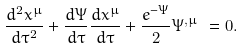Convert formula to latex. <formula><loc_0><loc_0><loc_500><loc_500>\frac { d ^ { 2 } x ^ { \mu } } { d \tau ^ { 2 } } + \frac { d \Psi } { d \tau } \frac { d x ^ { \mu } } { d \tau } + \frac { e ^ { - \Psi } } { 2 } \Psi ^ { , \mu } \text { } = 0 .</formula> 